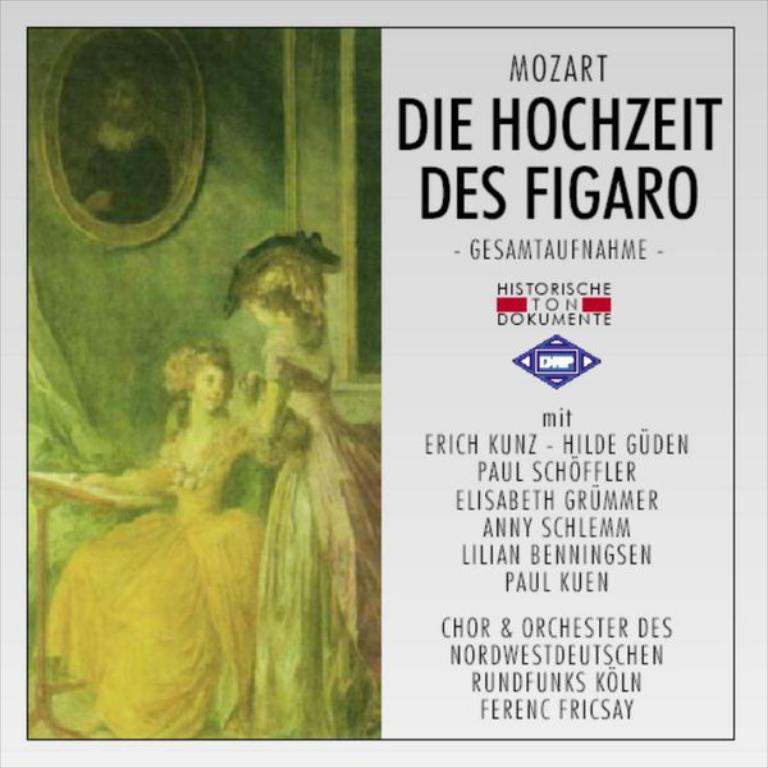<image>
Render a clear and concise summary of the photo. A brochure for an orchestra featuring Erich Kunz, Hilde Guden and some other people. 